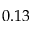<formula> <loc_0><loc_0><loc_500><loc_500>0 . 1 3</formula> 